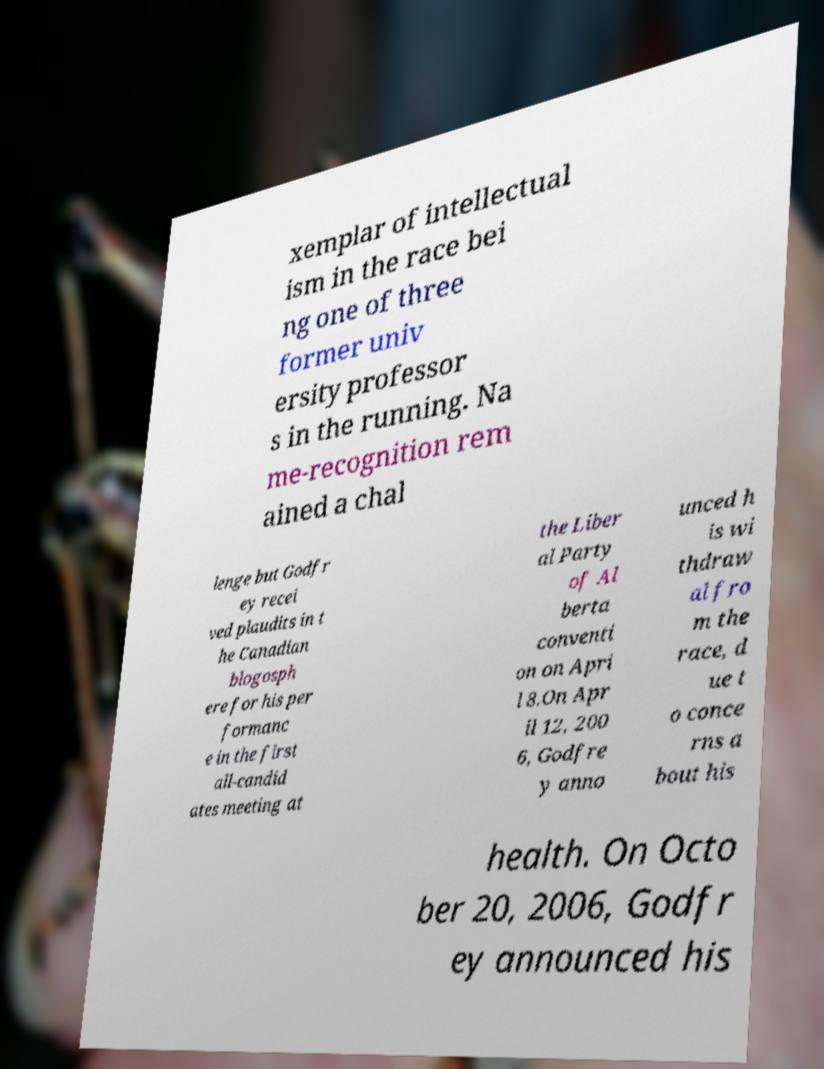Could you assist in decoding the text presented in this image and type it out clearly? xemplar of intellectual ism in the race bei ng one of three former univ ersity professor s in the running. Na me-recognition rem ained a chal lenge but Godfr ey recei ved plaudits in t he Canadian blogosph ere for his per formanc e in the first all-candid ates meeting at the Liber al Party of Al berta conventi on on Apri l 8.On Apr il 12, 200 6, Godfre y anno unced h is wi thdraw al fro m the race, d ue t o conce rns a bout his health. On Octo ber 20, 2006, Godfr ey announced his 